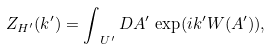Convert formula to latex. <formula><loc_0><loc_0><loc_500><loc_500>Z _ { H ^ { \prime } } ( k ^ { \prime } ) = \int _ { \ U ^ { \prime } } D A ^ { \prime } \, \exp ( i { k ^ { \prime } } W ( A ^ { \prime } ) ) ,</formula> 